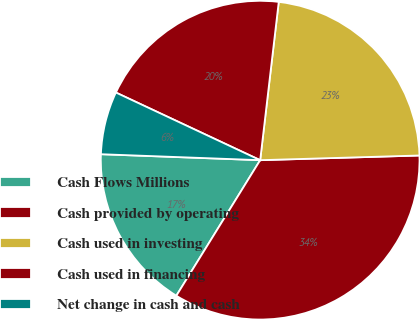Convert chart to OTSL. <chart><loc_0><loc_0><loc_500><loc_500><pie_chart><fcel>Cash Flows Millions<fcel>Cash provided by operating<fcel>Cash used in investing<fcel>Cash used in financing<fcel>Net change in cash and cash<nl><fcel>16.78%<fcel>34.28%<fcel>22.67%<fcel>19.88%<fcel>6.38%<nl></chart> 